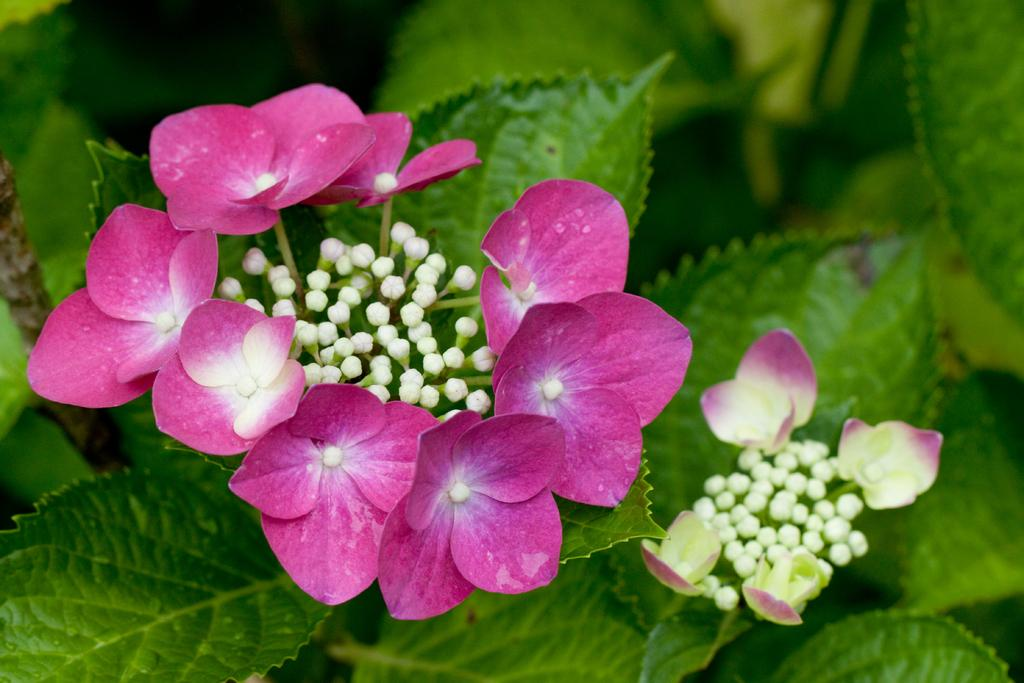What type of living organisms can be seen in the image? Plants and flowers can be seen in the image. Can you describe any specific features of the plants in the image? Yes, there are buds visible in the image. Where is the swing located in the image? There is no swing present in the image. What type of window can be seen in the image? There is no window present in the image. Where might the lunchroom be located in the image? There is no lunchroom present in the image. 